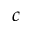<formula> <loc_0><loc_0><loc_500><loc_500>c</formula> 